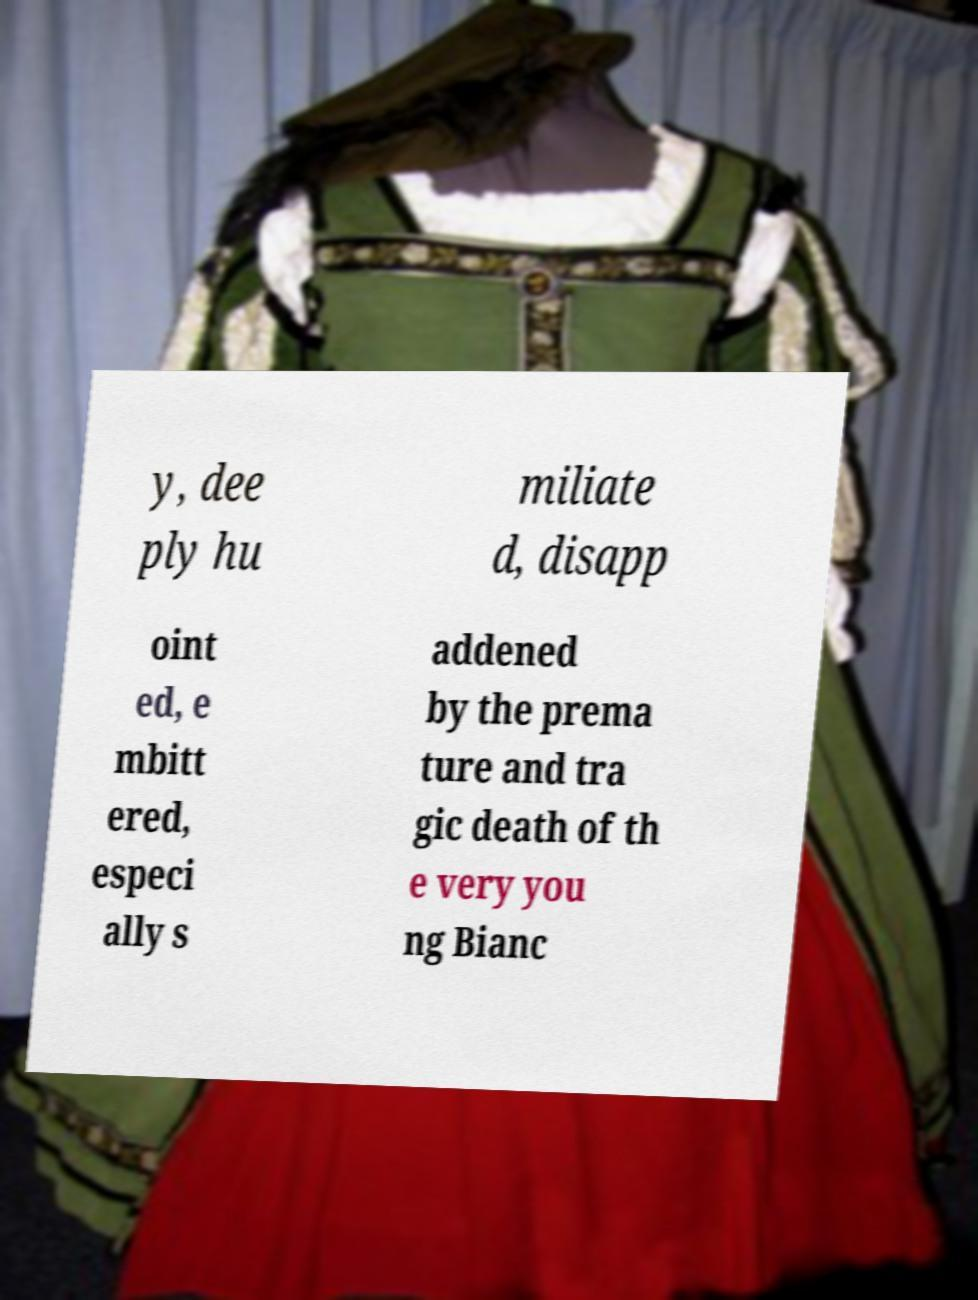Please identify and transcribe the text found in this image. y, dee ply hu miliate d, disapp oint ed, e mbitt ered, especi ally s addened by the prema ture and tra gic death of th e very you ng Bianc 